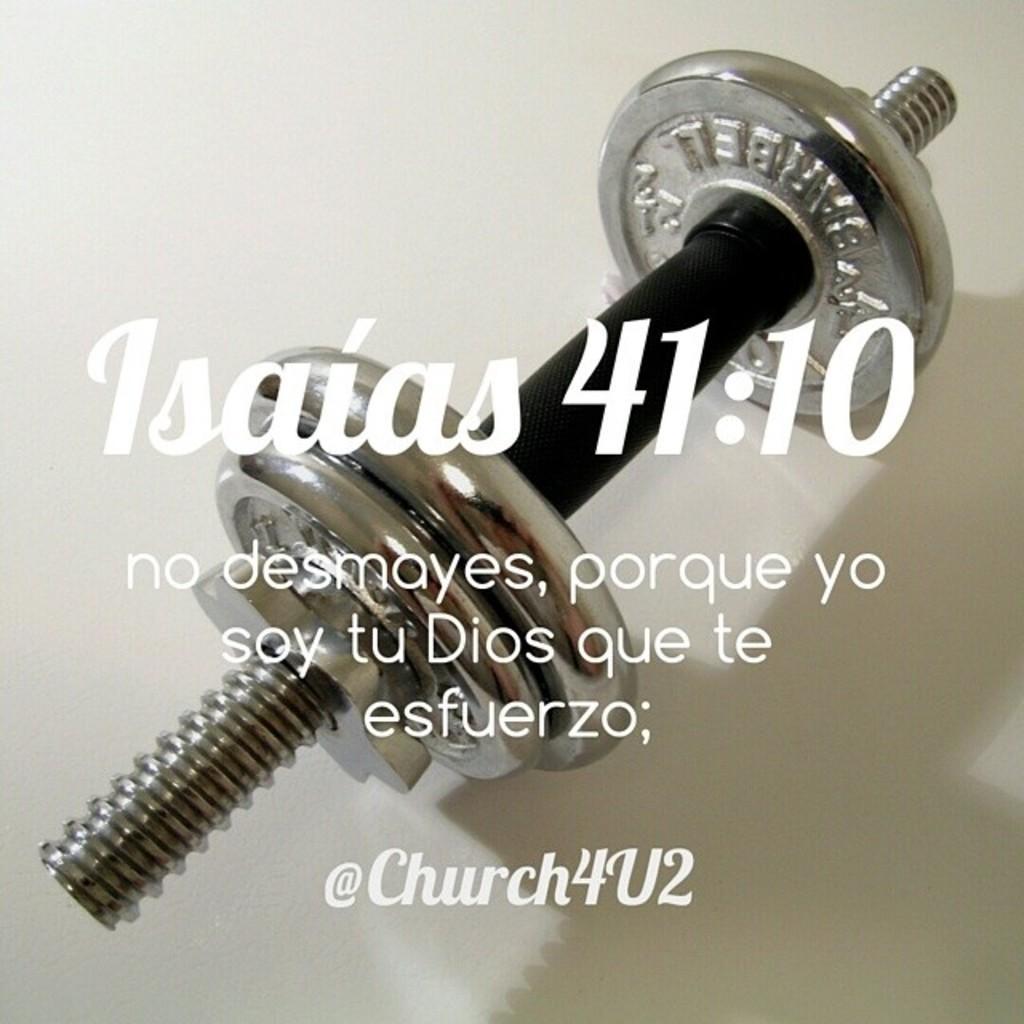Could you give a brief overview of what you see in this image? In this picture we can see the white surface. We can see an object and words. 